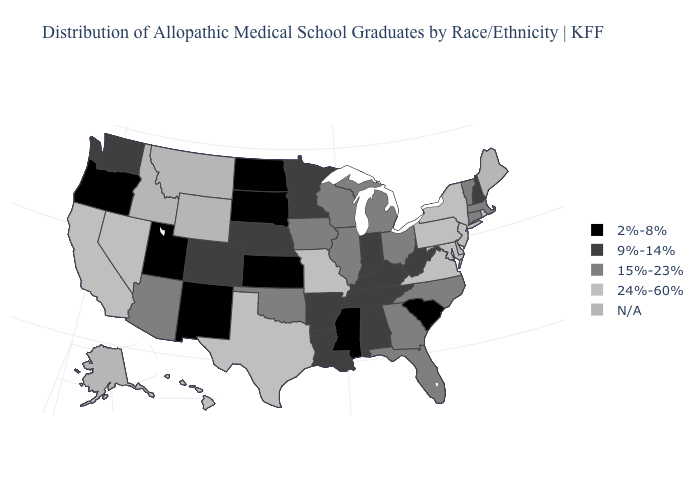Which states hav the highest value in the MidWest?
Write a very short answer. Missouri. What is the value of West Virginia?
Concise answer only. 9%-14%. Name the states that have a value in the range N/A?
Quick response, please. Alaska, Delaware, Idaho, Maine, Montana, Wyoming. Does New Hampshire have the highest value in the USA?
Keep it brief. No. Does the first symbol in the legend represent the smallest category?
Concise answer only. Yes. What is the value of Arkansas?
Be succinct. 9%-14%. Does the map have missing data?
Give a very brief answer. Yes. What is the lowest value in the MidWest?
Keep it brief. 2%-8%. What is the value of Iowa?
Concise answer only. 15%-23%. Name the states that have a value in the range 24%-60%?
Quick response, please. California, Hawaii, Maryland, Missouri, Nevada, New Jersey, New York, Pennsylvania, Rhode Island, Texas, Virginia. What is the value of North Carolina?
Quick response, please. 15%-23%. Which states have the highest value in the USA?
Give a very brief answer. California, Hawaii, Maryland, Missouri, Nevada, New Jersey, New York, Pennsylvania, Rhode Island, Texas, Virginia. Name the states that have a value in the range N/A?
Keep it brief. Alaska, Delaware, Idaho, Maine, Montana, Wyoming. 